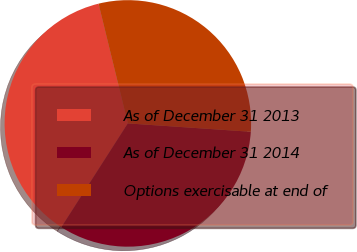Convert chart. <chart><loc_0><loc_0><loc_500><loc_500><pie_chart><fcel>As of December 31 2013<fcel>As of December 31 2014<fcel>Options exercisable at end of<nl><fcel>37.11%<fcel>32.99%<fcel>29.9%<nl></chart> 